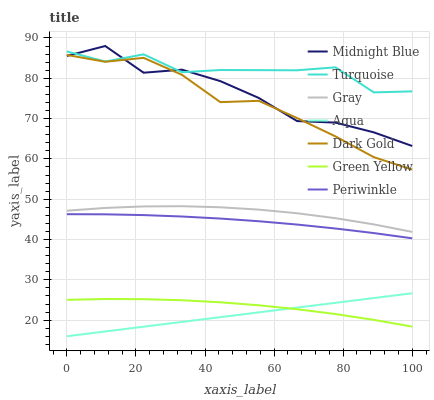Does Aqua have the minimum area under the curve?
Answer yes or no. Yes. Does Turquoise have the maximum area under the curve?
Answer yes or no. Yes. Does Midnight Blue have the minimum area under the curve?
Answer yes or no. No. Does Midnight Blue have the maximum area under the curve?
Answer yes or no. No. Is Aqua the smoothest?
Answer yes or no. Yes. Is Midnight Blue the roughest?
Answer yes or no. Yes. Is Turquoise the smoothest?
Answer yes or no. No. Is Turquoise the roughest?
Answer yes or no. No. Does Aqua have the lowest value?
Answer yes or no. Yes. Does Midnight Blue have the lowest value?
Answer yes or no. No. Does Midnight Blue have the highest value?
Answer yes or no. Yes. Does Turquoise have the highest value?
Answer yes or no. No. Is Aqua less than Periwinkle?
Answer yes or no. Yes. Is Midnight Blue greater than Green Yellow?
Answer yes or no. Yes. Does Green Yellow intersect Aqua?
Answer yes or no. Yes. Is Green Yellow less than Aqua?
Answer yes or no. No. Is Green Yellow greater than Aqua?
Answer yes or no. No. Does Aqua intersect Periwinkle?
Answer yes or no. No. 